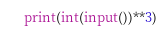Convert code to text. <code><loc_0><loc_0><loc_500><loc_500><_Python_>print(int(input())**3)</code> 